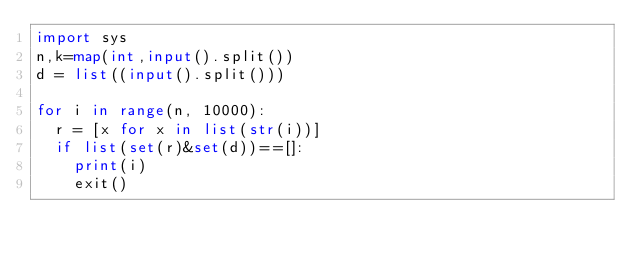<code> <loc_0><loc_0><loc_500><loc_500><_Python_>import sys
n,k=map(int,input().split())
d = list((input().split()))

for i in range(n, 10000):
  r = [x for x in list(str(i))]
  if list(set(r)&set(d))==[]:
    print(i)
    exit()</code> 